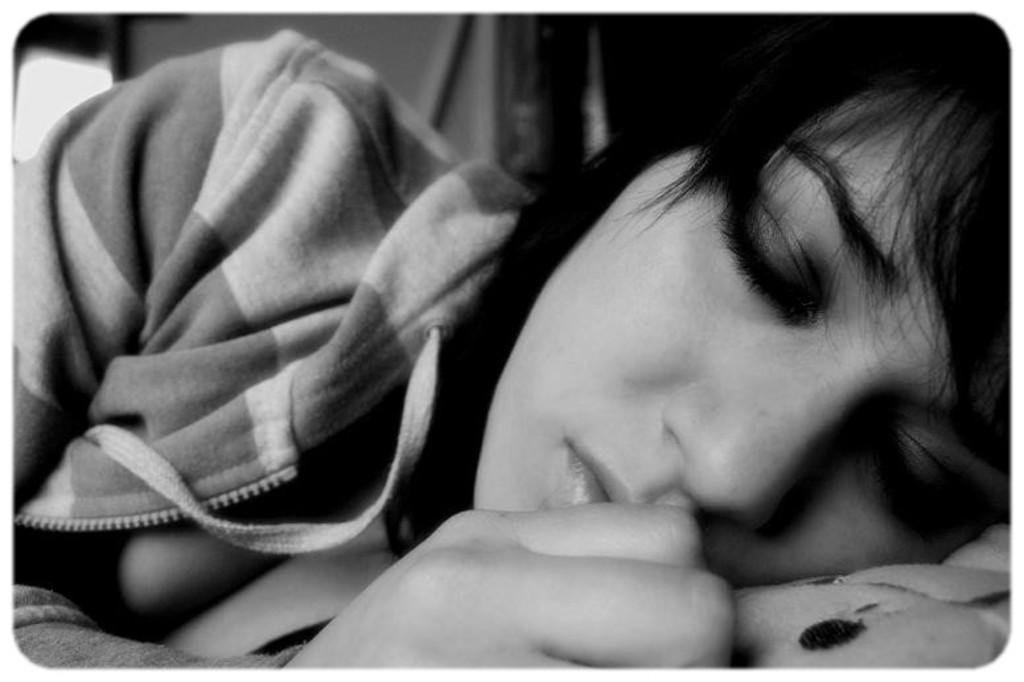How would you summarize this image in a sentence or two? In the center of the image we can see woman sleeping on the bed. 